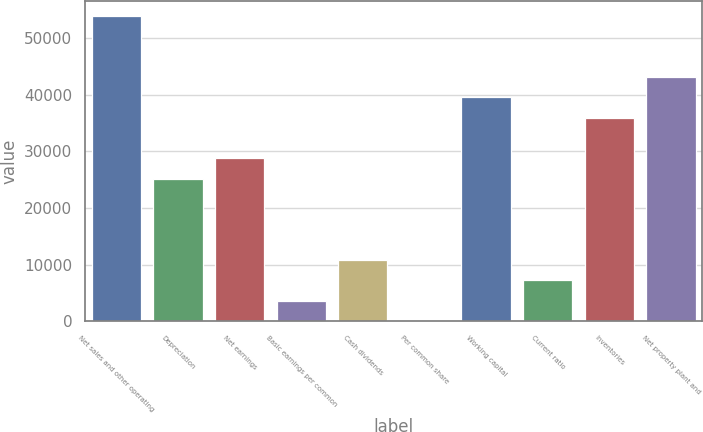Convert chart. <chart><loc_0><loc_0><loc_500><loc_500><bar_chart><fcel>Net sales and other operating<fcel>Depreciation<fcel>Net earnings<fcel>Basic earnings per common<fcel>Cash dividends<fcel>Per common share<fcel>Working capital<fcel>Current ratio<fcel>Inventories<fcel>Net property plant and<nl><fcel>53914.4<fcel>25160.2<fcel>28754.5<fcel>3594.59<fcel>10783.1<fcel>0.32<fcel>39537.3<fcel>7188.86<fcel>35943<fcel>43131.6<nl></chart> 